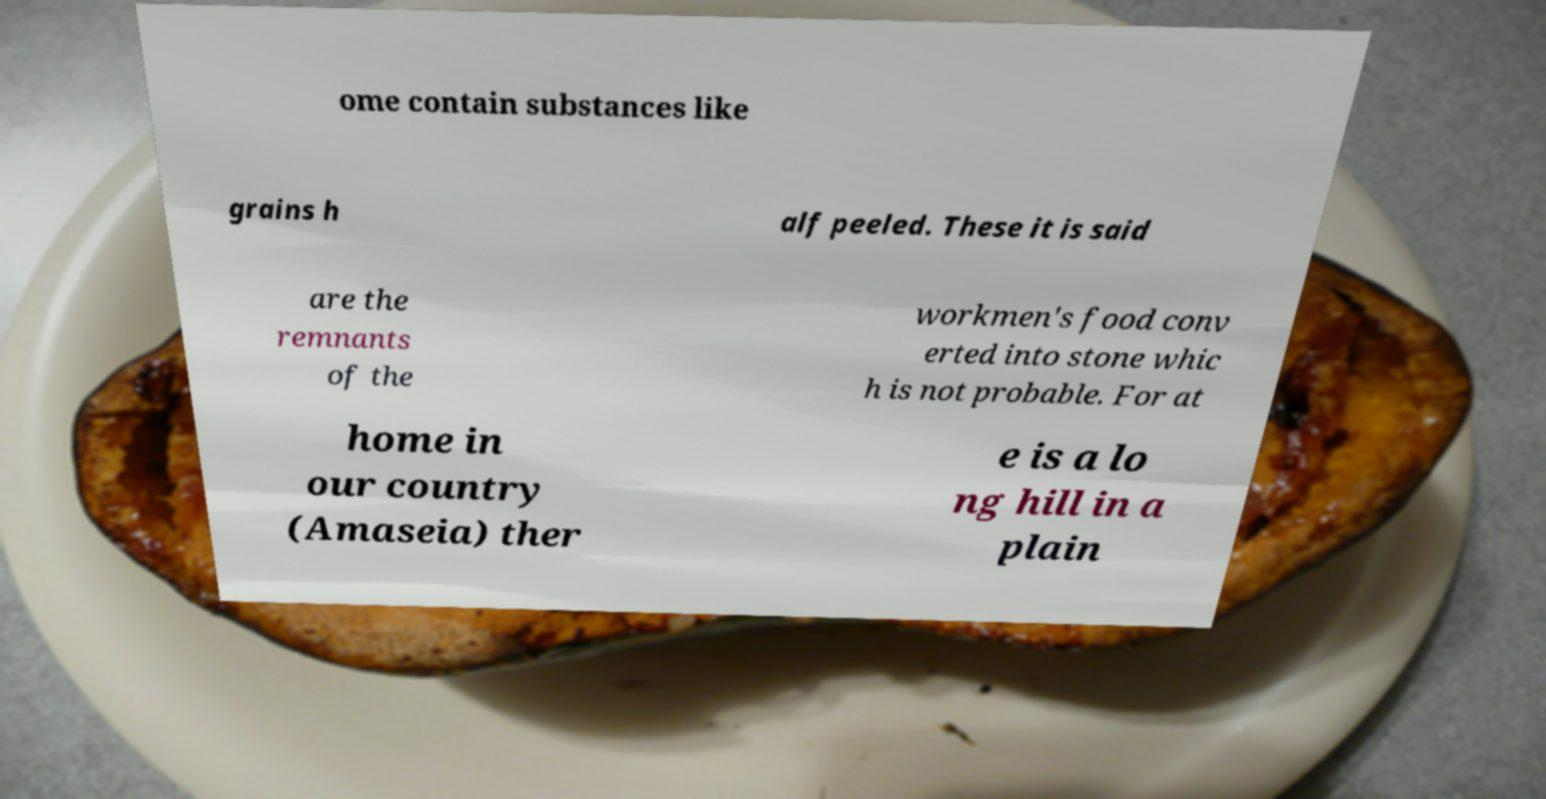Can you accurately transcribe the text from the provided image for me? ome contain substances like grains h alf peeled. These it is said are the remnants of the workmen's food conv erted into stone whic h is not probable. For at home in our country (Amaseia) ther e is a lo ng hill in a plain 